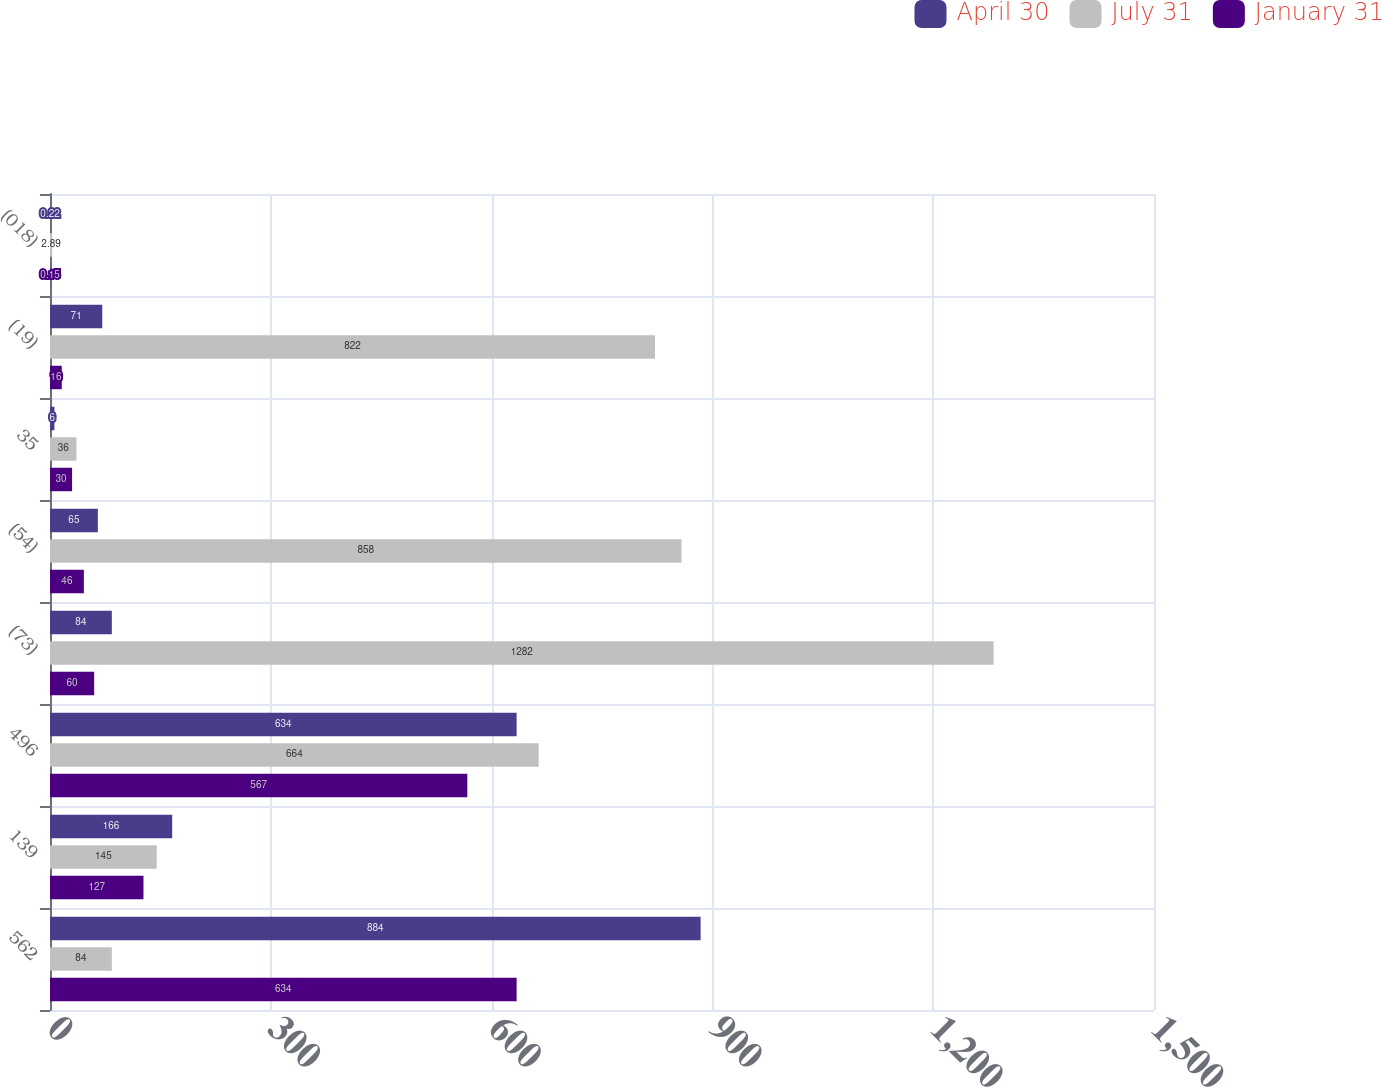<chart> <loc_0><loc_0><loc_500><loc_500><stacked_bar_chart><ecel><fcel>562<fcel>139<fcel>496<fcel>(73)<fcel>(54)<fcel>35<fcel>(19)<fcel>(018)<nl><fcel>April 30<fcel>884<fcel>166<fcel>634<fcel>84<fcel>65<fcel>6<fcel>71<fcel>0.22<nl><fcel>July 31<fcel>84<fcel>145<fcel>664<fcel>1282<fcel>858<fcel>36<fcel>822<fcel>2.89<nl><fcel>January 31<fcel>634<fcel>127<fcel>567<fcel>60<fcel>46<fcel>30<fcel>16<fcel>0.15<nl></chart> 